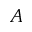Convert formula to latex. <formula><loc_0><loc_0><loc_500><loc_500>A</formula> 